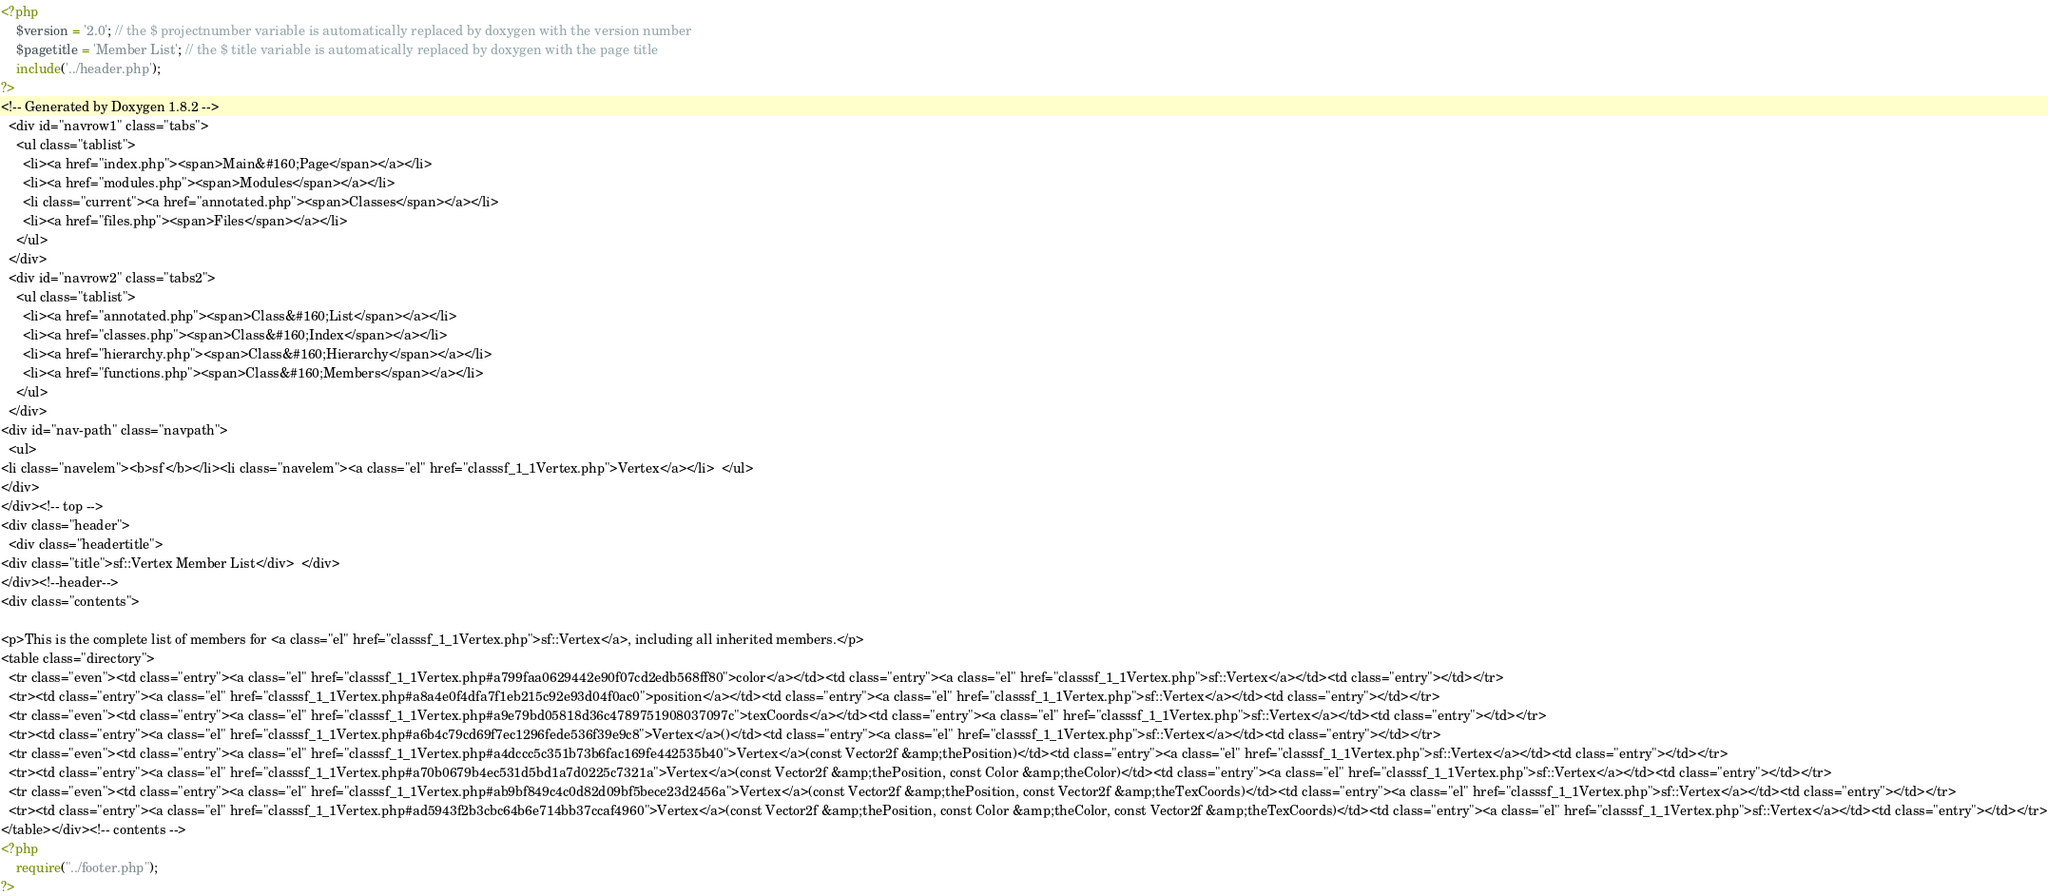<code> <loc_0><loc_0><loc_500><loc_500><_PHP_><?php
    $version = '2.0'; // the $ projectnumber variable is automatically replaced by doxygen with the version number
    $pagetitle = 'Member List'; // the $ title variable is automatically replaced by doxygen with the page title
    include('../header.php');
?>
<!-- Generated by Doxygen 1.8.2 -->
  <div id="navrow1" class="tabs">
    <ul class="tablist">
      <li><a href="index.php"><span>Main&#160;Page</span></a></li>
      <li><a href="modules.php"><span>Modules</span></a></li>
      <li class="current"><a href="annotated.php"><span>Classes</span></a></li>
      <li><a href="files.php"><span>Files</span></a></li>
    </ul>
  </div>
  <div id="navrow2" class="tabs2">
    <ul class="tablist">
      <li><a href="annotated.php"><span>Class&#160;List</span></a></li>
      <li><a href="classes.php"><span>Class&#160;Index</span></a></li>
      <li><a href="hierarchy.php"><span>Class&#160;Hierarchy</span></a></li>
      <li><a href="functions.php"><span>Class&#160;Members</span></a></li>
    </ul>
  </div>
<div id="nav-path" class="navpath">
  <ul>
<li class="navelem"><b>sf</b></li><li class="navelem"><a class="el" href="classsf_1_1Vertex.php">Vertex</a></li>  </ul>
</div>
</div><!-- top -->
<div class="header">
  <div class="headertitle">
<div class="title">sf::Vertex Member List</div>  </div>
</div><!--header-->
<div class="contents">

<p>This is the complete list of members for <a class="el" href="classsf_1_1Vertex.php">sf::Vertex</a>, including all inherited members.</p>
<table class="directory">
  <tr class="even"><td class="entry"><a class="el" href="classsf_1_1Vertex.php#a799faa0629442e90f07cd2edb568ff80">color</a></td><td class="entry"><a class="el" href="classsf_1_1Vertex.php">sf::Vertex</a></td><td class="entry"></td></tr>
  <tr><td class="entry"><a class="el" href="classsf_1_1Vertex.php#a8a4e0f4dfa7f1eb215c92e93d04f0ac0">position</a></td><td class="entry"><a class="el" href="classsf_1_1Vertex.php">sf::Vertex</a></td><td class="entry"></td></tr>
  <tr class="even"><td class="entry"><a class="el" href="classsf_1_1Vertex.php#a9e79bd05818d36c4789751908037097c">texCoords</a></td><td class="entry"><a class="el" href="classsf_1_1Vertex.php">sf::Vertex</a></td><td class="entry"></td></tr>
  <tr><td class="entry"><a class="el" href="classsf_1_1Vertex.php#a6b4c79cd69f7ec1296fede536f39e9c8">Vertex</a>()</td><td class="entry"><a class="el" href="classsf_1_1Vertex.php">sf::Vertex</a></td><td class="entry"></td></tr>
  <tr class="even"><td class="entry"><a class="el" href="classsf_1_1Vertex.php#a4dccc5c351b73b6fac169fe442535b40">Vertex</a>(const Vector2f &amp;thePosition)</td><td class="entry"><a class="el" href="classsf_1_1Vertex.php">sf::Vertex</a></td><td class="entry"></td></tr>
  <tr><td class="entry"><a class="el" href="classsf_1_1Vertex.php#a70b0679b4ec531d5bd1a7d0225c7321a">Vertex</a>(const Vector2f &amp;thePosition, const Color &amp;theColor)</td><td class="entry"><a class="el" href="classsf_1_1Vertex.php">sf::Vertex</a></td><td class="entry"></td></tr>
  <tr class="even"><td class="entry"><a class="el" href="classsf_1_1Vertex.php#ab9bf849c4c0d82d09bf5bece23d2456a">Vertex</a>(const Vector2f &amp;thePosition, const Vector2f &amp;theTexCoords)</td><td class="entry"><a class="el" href="classsf_1_1Vertex.php">sf::Vertex</a></td><td class="entry"></td></tr>
  <tr><td class="entry"><a class="el" href="classsf_1_1Vertex.php#ad5943f2b3cbc64b6e714bb37ccaf4960">Vertex</a>(const Vector2f &amp;thePosition, const Color &amp;theColor, const Vector2f &amp;theTexCoords)</td><td class="entry"><a class="el" href="classsf_1_1Vertex.php">sf::Vertex</a></td><td class="entry"></td></tr>
</table></div><!-- contents -->
<?php
    require("../footer.php");
?>
</code> 